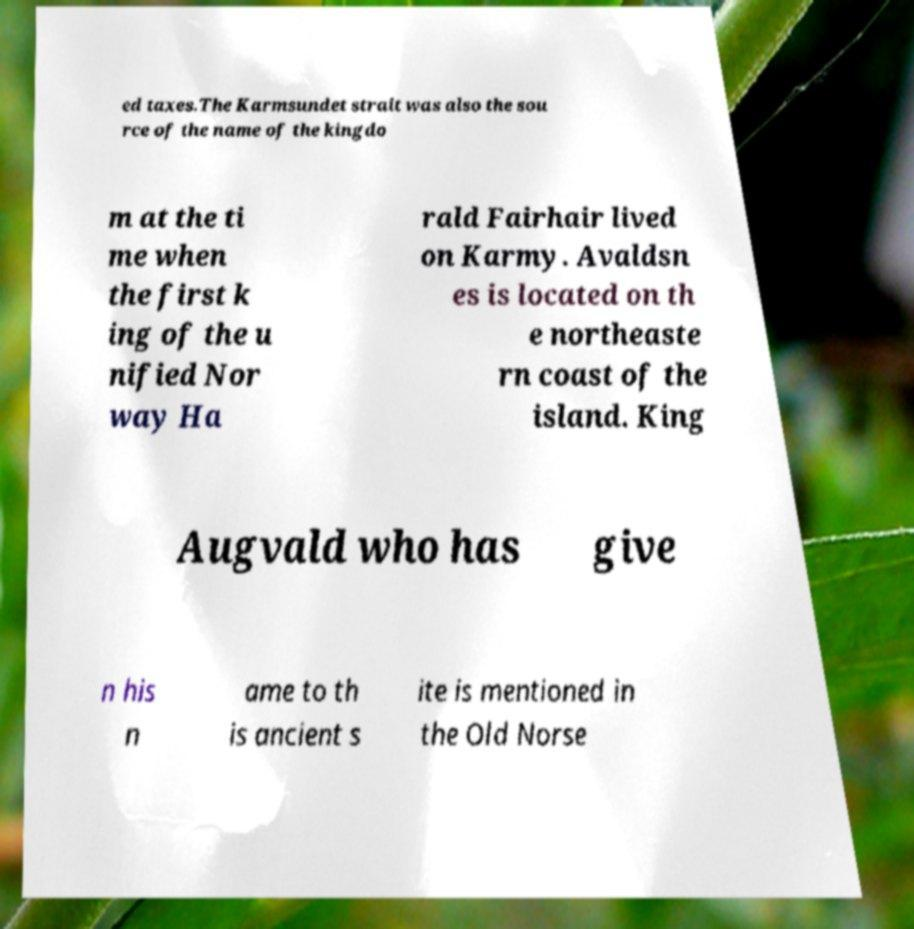Could you extract and type out the text from this image? ed taxes.The Karmsundet strait was also the sou rce of the name of the kingdo m at the ti me when the first k ing of the u nified Nor way Ha rald Fairhair lived on Karmy. Avaldsn es is located on th e northeaste rn coast of the island. King Augvald who has give n his n ame to th is ancient s ite is mentioned in the Old Norse 